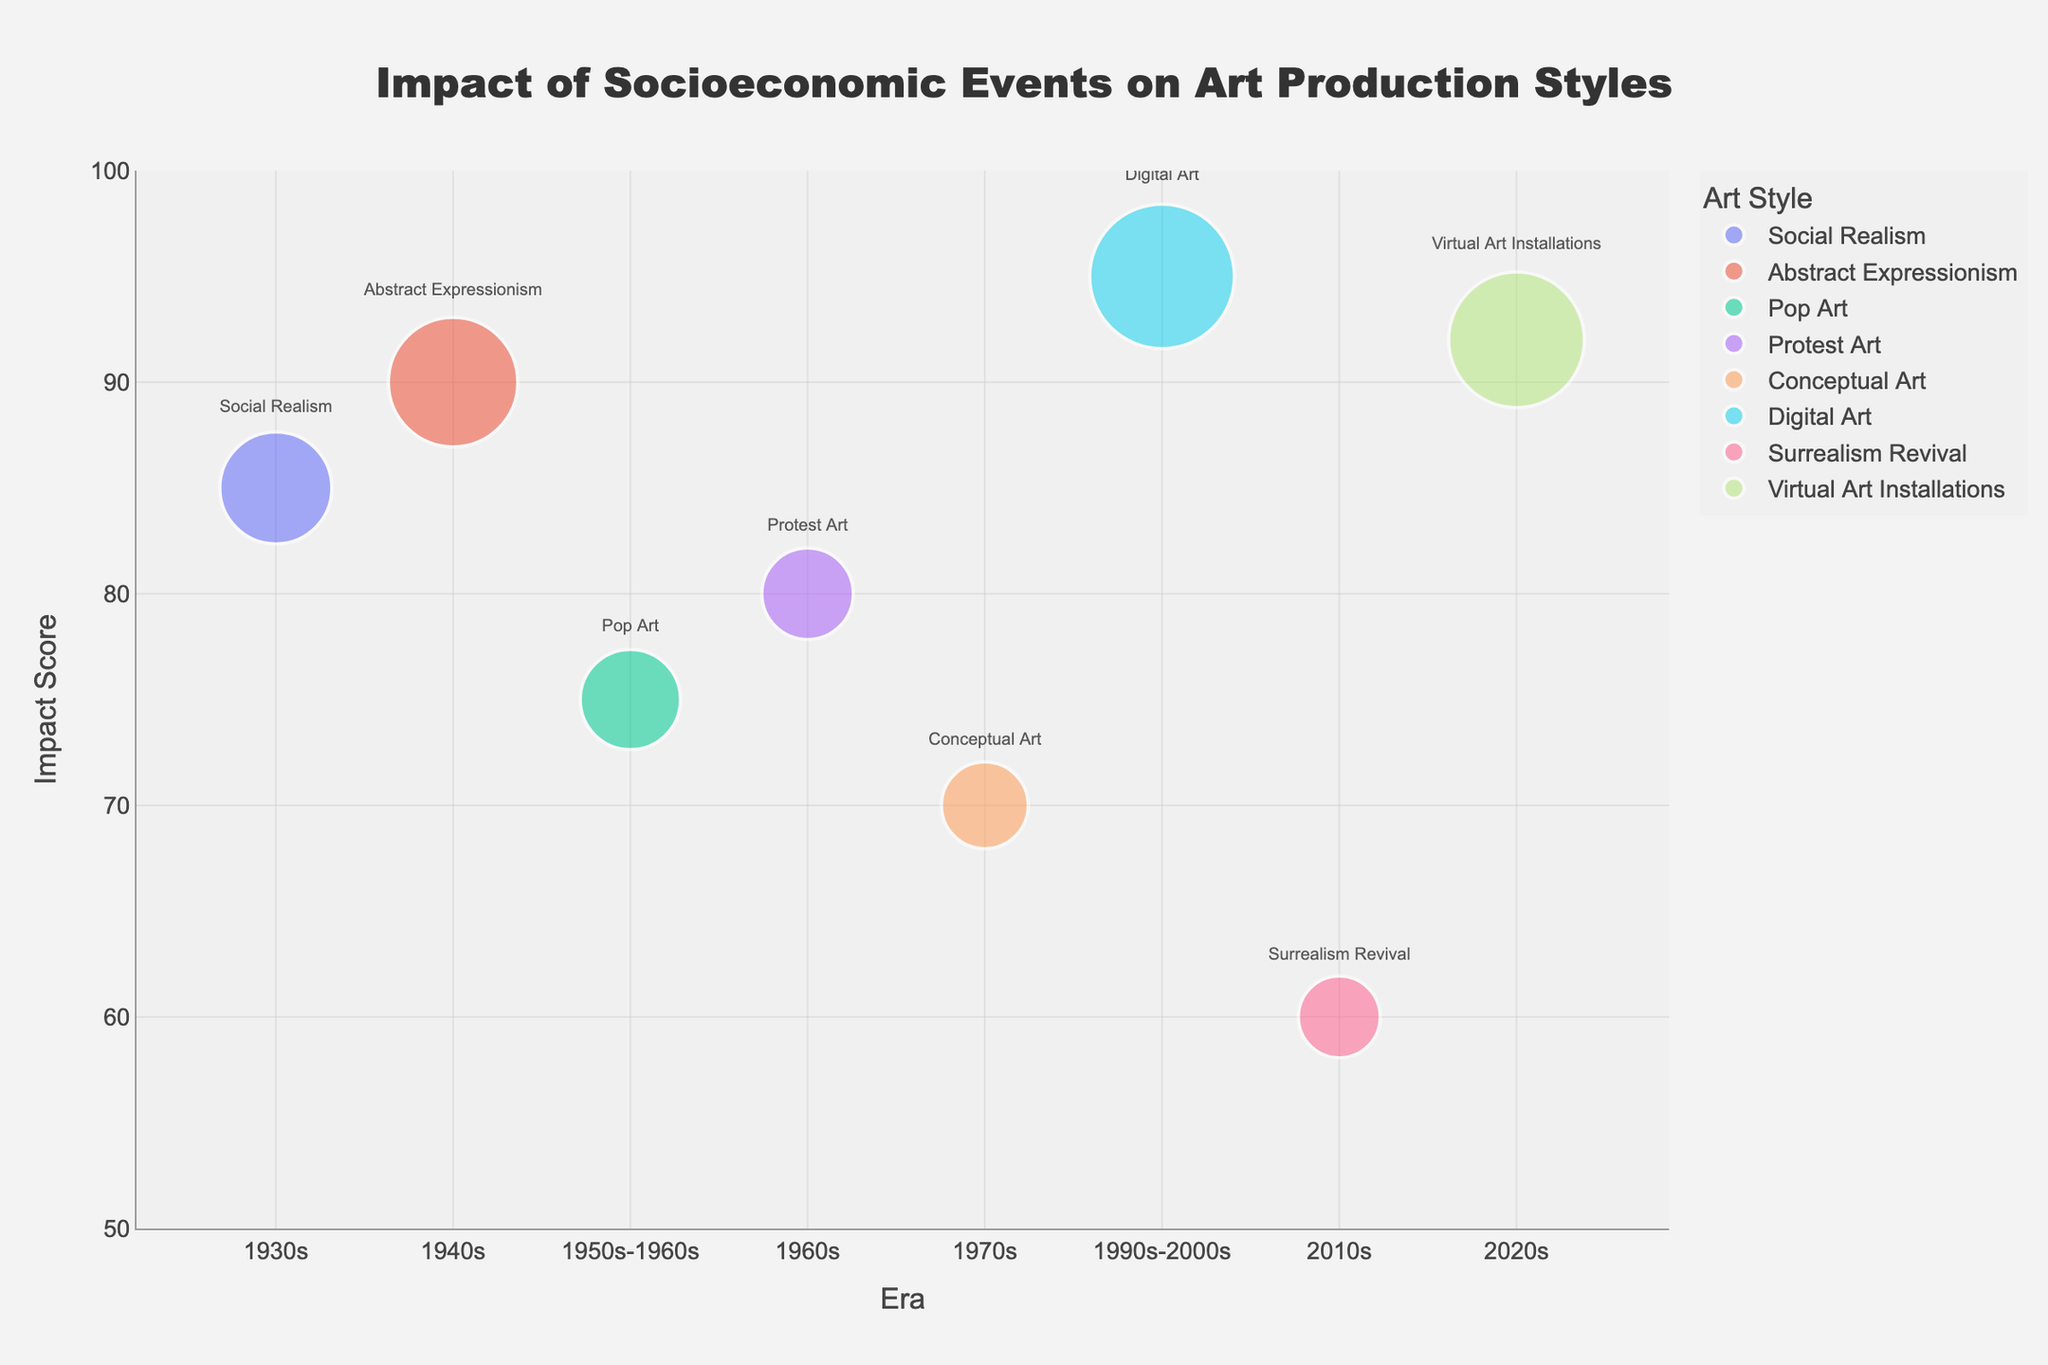What is the title of the figure? The title is displayed at the top center of the figure, and it reads 'Impact of Socioeconomic Events on Art Production Styles'.
Answer: Impact of Socioeconomic Events on Art Production Styles In which era did Digital Art have the highest number of pieces? The bubble for Digital Art is in the era labeled '1990s-2000s', and it is the largest in terms of size, indicating the highest number of pieces.
Answer: 1990s-2000s Which art style is associated with the COVID-19 Pandemic, and what is its Impact Score? The COVID-19 Pandemic is associated with Virtual Art Installations, indicated by the bubble in the 2020s era. The vertical position (y-axis) of this bubble shows an Impact Score of 92.
Answer: Virtual Art Installations, 92 How many eras are represented in the figure? The x-axis of the figure displays different eras, counting from the 1930s to the 2020s, there are 8 eras in total.
Answer: 8 Which socioeconomic event had the highest Impact Score, and what art style is associated with it? By looking at the y-axis and identifying the bubble positioned highest, we can see that the Digital Revolution in the 1990s-2000s has an Impact Score of 95. This event is associated with Digital Art.
Answer: Digital Revolution, Digital Art Compare the number of pieces between Social Realism and Surrealism Revival. How many more pieces does Social Realism have? Social Realism has a bubble size representing 150 pieces, and Surrealism Revival has a bubble size representing 80 pieces. The difference is 150 - 80 = 70 pieces.
Answer: 70 Which era experienced the lowest Impact Score and for which art style? By looking at the y-axis and finding the lowest bubble, the 2010s era had the lowest Impact Score of 60, associated with the Surrealism Revival art style.
Answer: 2010s, Surrealism Revival What is the combined total number of pieces for the events during the 1960s and 2020s? The number of pieces for the events in the 1960s is 100, and for the 2020s is 220. The combined total is 100 + 220 = 320 pieces.
Answer: 320 How does the Impact Score of Abstract Expressionism compare to that of Virtual Art Installations? Abstract Expressionism (1940s, World War II) has an Impact Score of 90, while Virtual Art Installations (2020s, COVID-19 Pandemic) has an Impact Score of 92. The latter is higher by 2 points.
Answer: Virtual Art Installations is 2 points higher Identify the socioeconomic event with the smallest bubble in the figure. The smallest bubble in terms of size is associated with the 2008 Financial Crisis in the 2010s, representing 80 pieces.
Answer: 2008 Financial Crisis 